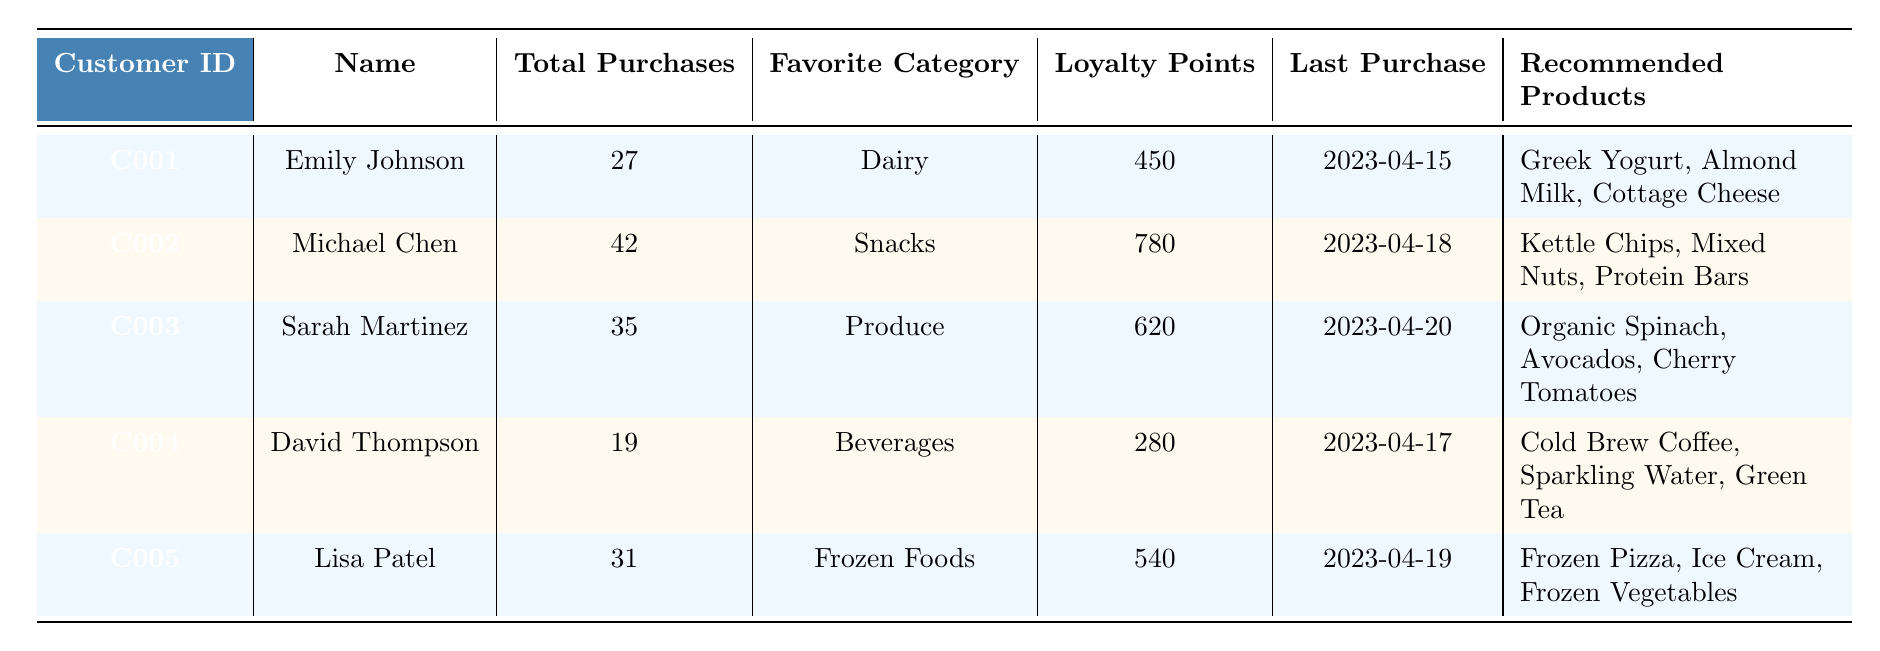What is the favorite category of Emily Johnson? Emily Johnson's favorite category is listed in the table under the "Favorite Category" column. It shows "Dairy" as her favorite.
Answer: Dairy How many total purchases has Michael Chen made? The table indicates that Michael Chen has made a total of 42 purchases, which is stated in the "Total Purchases" column.
Answer: 42 Which customer has the highest loyalty points? To find this, we compare the loyalty points listed for each customer. Michael Chen has 780 points, which is more than the others.
Answer: Michael Chen What are the recommended products for Sarah Martinez? The table provides a list of recommended products for each customer, and for Sarah Martinez, the recommended products are "Organic Spinach, Avocados, Cherry Tomatoes."
Answer: Organic Spinach, Avocados, Cherry Tomatoes How many customers have their last purchase after April 16, 2023? We check the "Last Purchase" dates. Emily Johnson, Michael Chen, Sarah Martinez, and Lisa Patel all have last purchases after April 16, which totals four customers.
Answer: 4 What is the average number of total purchases across all customers? We sum the total purchases (27 + 42 + 35 + 19 + 31 = 154), then divide by the number of customers (5). So the average is 154/5 = 30.8.
Answer: 30.8 Does Lisa Patel prefer Frozen Foods? The table indicates her favorite category is "Frozen Foods," which confirms her preference.
Answer: Yes Which two categories are represented by the customers with the least and most total purchases? David Thompson has the least with 19 purchases (Beverages), and Michael Chen has the most with 42 purchases (Snacks).
Answer: Beverages, Snacks What is the last purchase date for the customer with the lowest loyalty points? David Thompson has the lowest loyalty points at 280. The table shows his last purchase date is 2023-04-17.
Answer: 2023-04-17 How many customers have total purchases greater than 30? We check the total purchases for each customer. Emily Johnson (27), Michael Chen (42), Sarah Martinez (35), and Lisa Patel (31) make it 3 customers with purchases greater than 30.
Answer: 3 